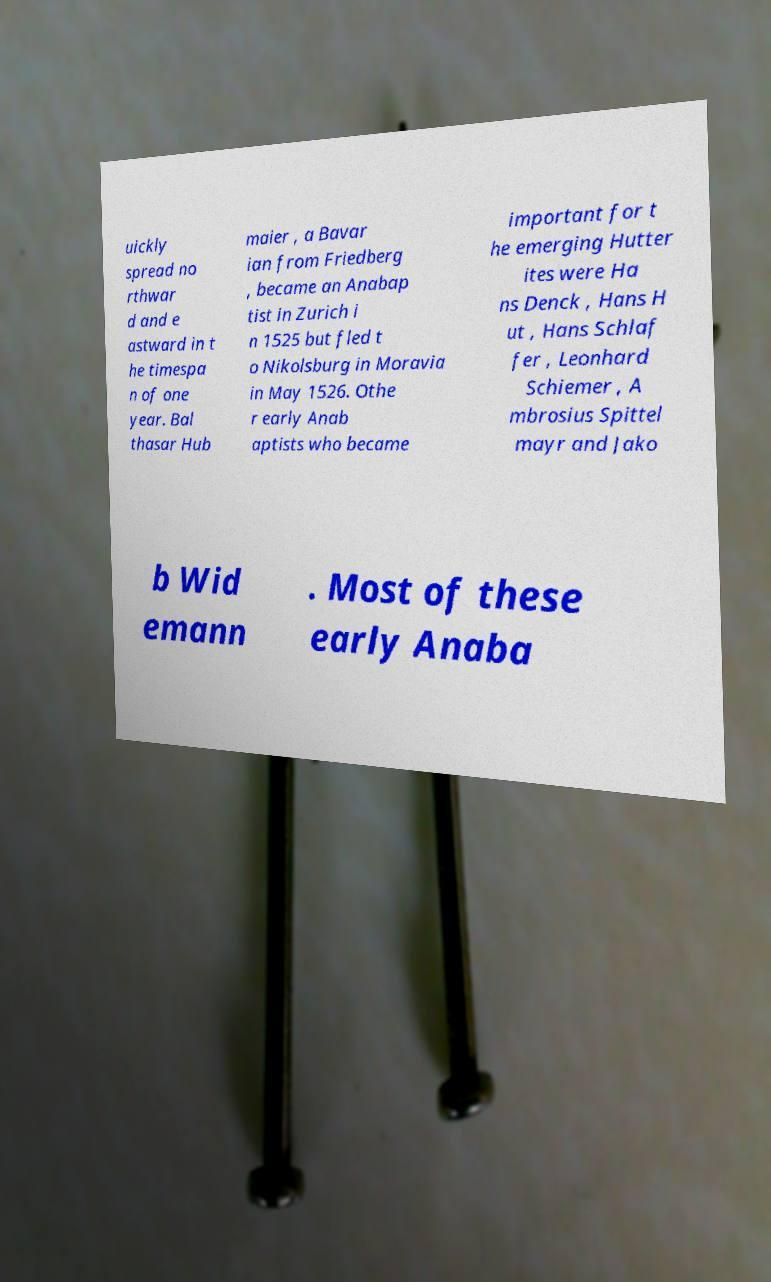Can you read and provide the text displayed in the image?This photo seems to have some interesting text. Can you extract and type it out for me? uickly spread no rthwar d and e astward in t he timespa n of one year. Bal thasar Hub maier , a Bavar ian from Friedberg , became an Anabap tist in Zurich i n 1525 but fled t o Nikolsburg in Moravia in May 1526. Othe r early Anab aptists who became important for t he emerging Hutter ites were Ha ns Denck , Hans H ut , Hans Schlaf fer , Leonhard Schiemer , A mbrosius Spittel mayr and Jako b Wid emann . Most of these early Anaba 